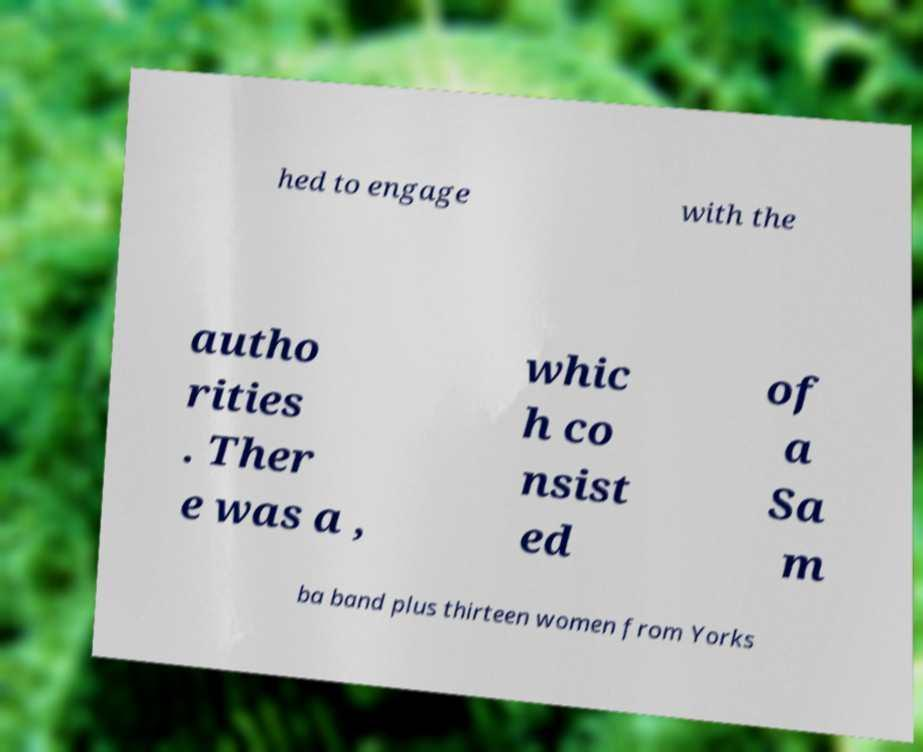Can you accurately transcribe the text from the provided image for me? hed to engage with the autho rities . Ther e was a , whic h co nsist ed of a Sa m ba band plus thirteen women from Yorks 